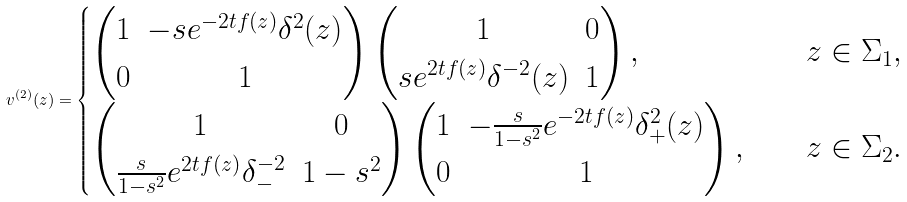Convert formula to latex. <formula><loc_0><loc_0><loc_500><loc_500>v ^ { ( 2 ) } ( z ) = \begin{cases} \begin{pmatrix} 1 & - s e ^ { - 2 t f ( z ) } \delta ^ { 2 } ( z ) \\ 0 & 1 \end{pmatrix} \begin{pmatrix} 1 & 0 \\ s e ^ { 2 t f ( z ) } \delta ^ { - 2 } ( z ) & 1 \end{pmatrix} , \quad & z \in \Sigma _ { 1 } , \\ \begin{pmatrix} 1 & 0 \\ \frac { s } { 1 - s ^ { 2 } } e ^ { 2 t f ( z ) } \delta _ { - } ^ { - 2 } & 1 - s ^ { 2 } \end{pmatrix} \begin{pmatrix} 1 & - \frac { s } { 1 - s ^ { 2 } } e ^ { - 2 t f ( z ) } \delta _ { + } ^ { 2 } ( z ) \\ 0 & 1 \end{pmatrix} , \quad & z \in \Sigma _ { 2 } . \end{cases}</formula> 